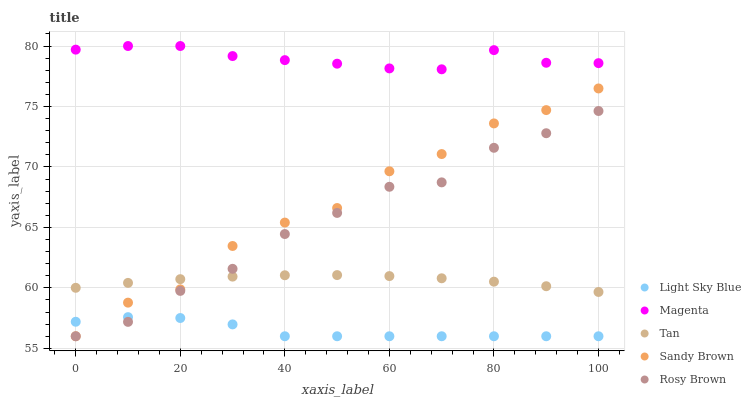Does Light Sky Blue have the minimum area under the curve?
Answer yes or no. Yes. Does Magenta have the maximum area under the curve?
Answer yes or no. Yes. Does Sandy Brown have the minimum area under the curve?
Answer yes or no. No. Does Sandy Brown have the maximum area under the curve?
Answer yes or no. No. Is Tan the smoothest?
Answer yes or no. Yes. Is Sandy Brown the roughest?
Answer yes or no. Yes. Is Light Sky Blue the smoothest?
Answer yes or no. No. Is Light Sky Blue the roughest?
Answer yes or no. No. Does Light Sky Blue have the lowest value?
Answer yes or no. Yes. Does Tan have the lowest value?
Answer yes or no. No. Does Magenta have the highest value?
Answer yes or no. Yes. Does Sandy Brown have the highest value?
Answer yes or no. No. Is Light Sky Blue less than Magenta?
Answer yes or no. Yes. Is Magenta greater than Sandy Brown?
Answer yes or no. Yes. Does Tan intersect Sandy Brown?
Answer yes or no. Yes. Is Tan less than Sandy Brown?
Answer yes or no. No. Is Tan greater than Sandy Brown?
Answer yes or no. No. Does Light Sky Blue intersect Magenta?
Answer yes or no. No. 